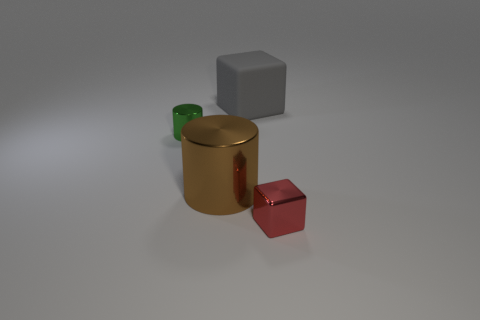Add 4 small green metallic cylinders. How many objects exist? 8 Add 2 big gray blocks. How many big gray blocks exist? 3 Subtract 0 cyan cylinders. How many objects are left? 4 Subtract all brown metallic things. Subtract all metallic cubes. How many objects are left? 2 Add 4 brown cylinders. How many brown cylinders are left? 5 